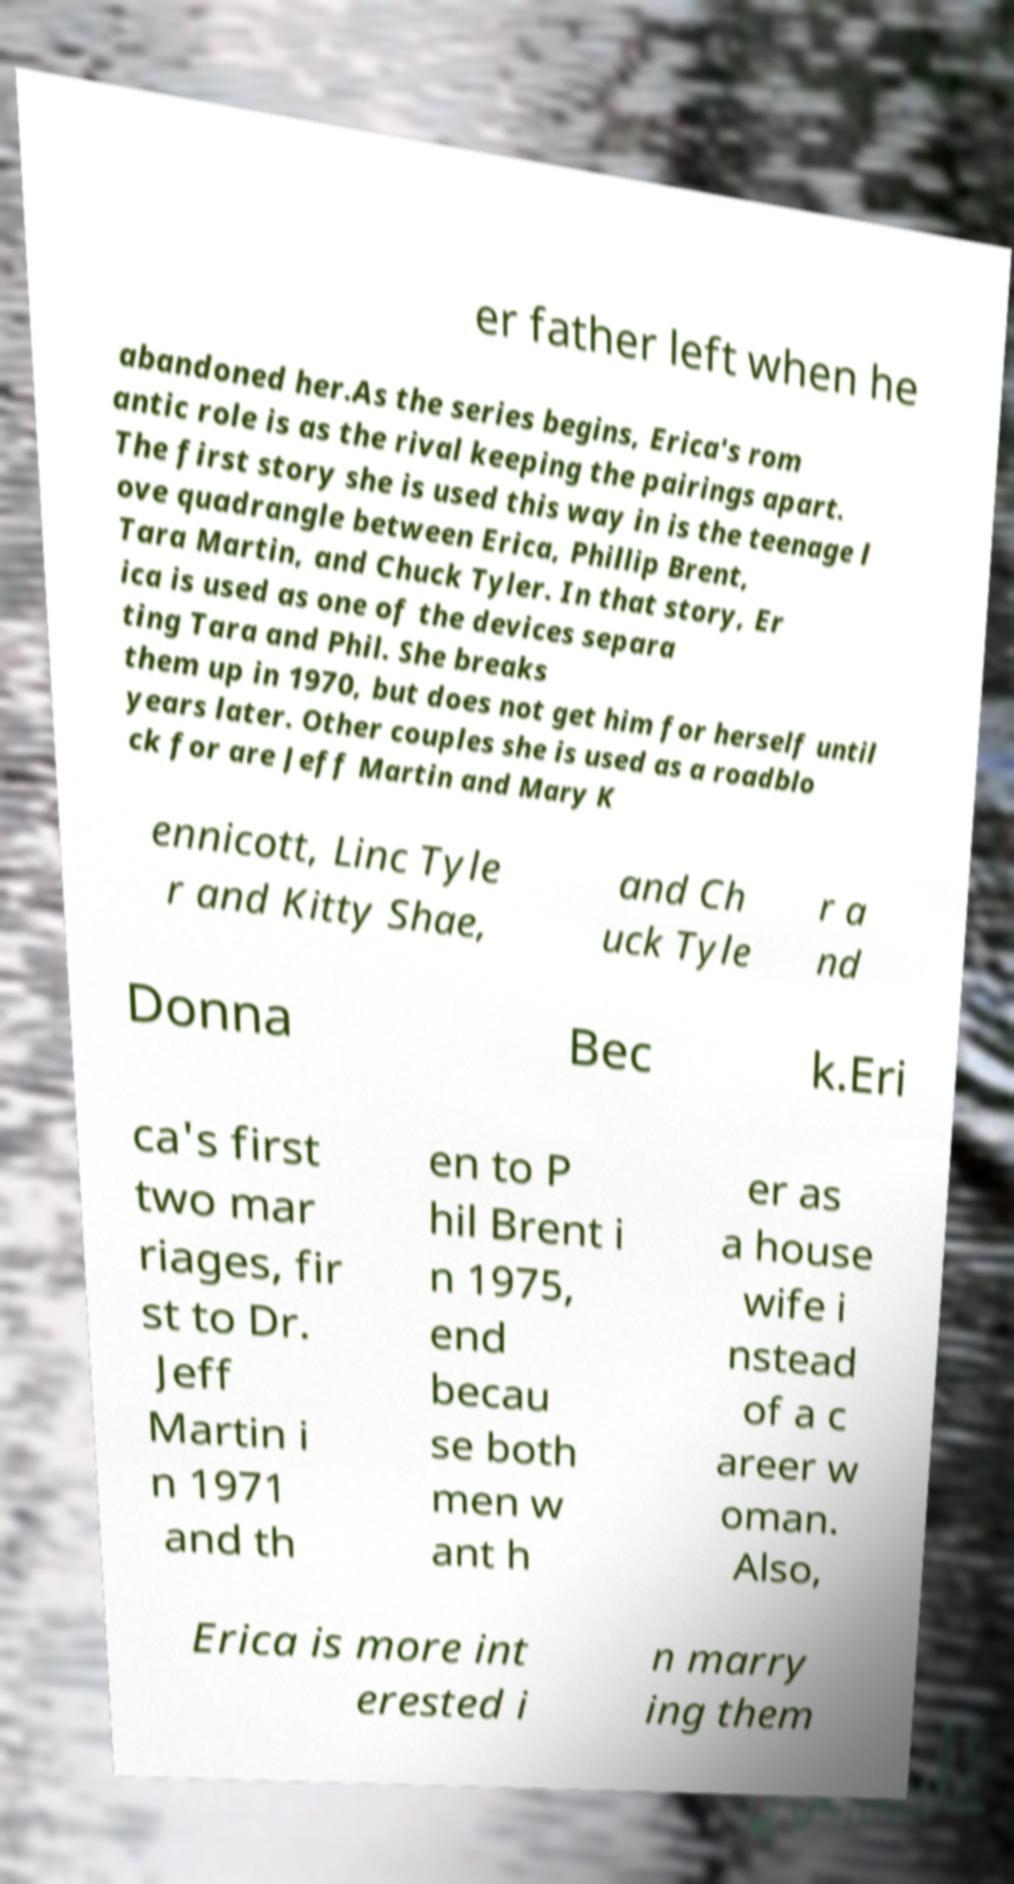Please read and relay the text visible in this image. What does it say? er father left when he abandoned her.As the series begins, Erica's rom antic role is as the rival keeping the pairings apart. The first story she is used this way in is the teenage l ove quadrangle between Erica, Phillip Brent, Tara Martin, and Chuck Tyler. In that story, Er ica is used as one of the devices separa ting Tara and Phil. She breaks them up in 1970, but does not get him for herself until years later. Other couples she is used as a roadblo ck for are Jeff Martin and Mary K ennicott, Linc Tyle r and Kitty Shae, and Ch uck Tyle r a nd Donna Bec k.Eri ca's first two mar riages, fir st to Dr. Jeff Martin i n 1971 and th en to P hil Brent i n 1975, end becau se both men w ant h er as a house wife i nstead of a c areer w oman. Also, Erica is more int erested i n marry ing them 